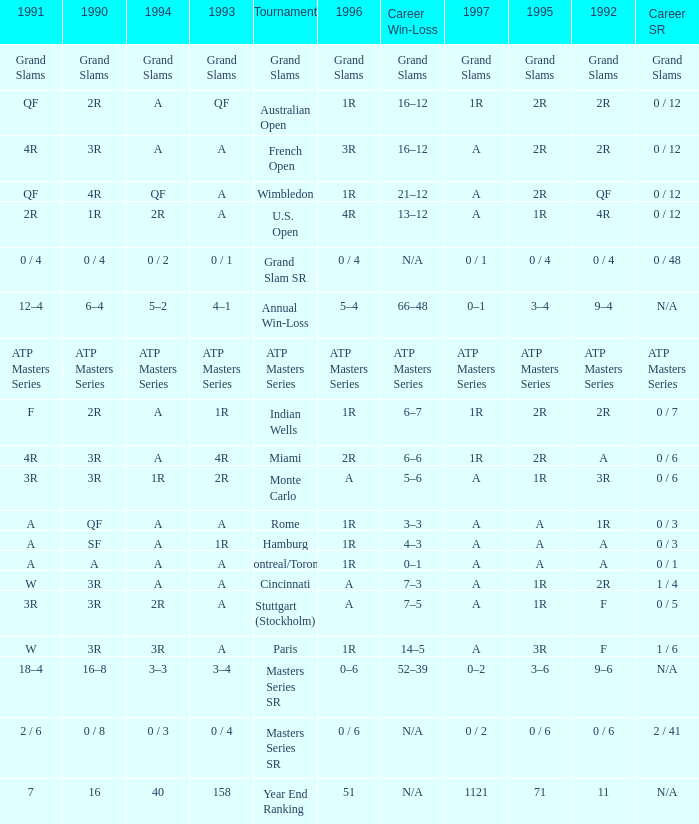What is Tournament, when Career SR is "ATP Masters Series"? ATP Masters Series. Write the full table. {'header': ['1991', '1990', '1994', '1993', 'Tournament', '1996', 'Career Win-Loss', '1997', '1995', '1992', 'Career SR'], 'rows': [['Grand Slams', 'Grand Slams', 'Grand Slams', 'Grand Slams', 'Grand Slams', 'Grand Slams', 'Grand Slams', 'Grand Slams', 'Grand Slams', 'Grand Slams', 'Grand Slams'], ['QF', '2R', 'A', 'QF', 'Australian Open', '1R', '16–12', '1R', '2R', '2R', '0 / 12'], ['4R', '3R', 'A', 'A', 'French Open', '3R', '16–12', 'A', '2R', '2R', '0 / 12'], ['QF', '4R', 'QF', 'A', 'Wimbledon', '1R', '21–12', 'A', '2R', 'QF', '0 / 12'], ['2R', '1R', '2R', 'A', 'U.S. Open', '4R', '13–12', 'A', '1R', '4R', '0 / 12'], ['0 / 4', '0 / 4', '0 / 2', '0 / 1', 'Grand Slam SR', '0 / 4', 'N/A', '0 / 1', '0 / 4', '0 / 4', '0 / 48'], ['12–4', '6–4', '5–2', '4–1', 'Annual Win-Loss', '5–4', '66–48', '0–1', '3–4', '9–4', 'N/A'], ['ATP Masters Series', 'ATP Masters Series', 'ATP Masters Series', 'ATP Masters Series', 'ATP Masters Series', 'ATP Masters Series', 'ATP Masters Series', 'ATP Masters Series', 'ATP Masters Series', 'ATP Masters Series', 'ATP Masters Series'], ['F', '2R', 'A', '1R', 'Indian Wells', '1R', '6–7', '1R', '2R', '2R', '0 / 7'], ['4R', '3R', 'A', '4R', 'Miami', '2R', '6–6', '1R', '2R', 'A', '0 / 6'], ['3R', '3R', '1R', '2R', 'Monte Carlo', 'A', '5–6', 'A', '1R', '3R', '0 / 6'], ['A', 'QF', 'A', 'A', 'Rome', '1R', '3–3', 'A', 'A', '1R', '0 / 3'], ['A', 'SF', 'A', '1R', 'Hamburg', '1R', '4–3', 'A', 'A', 'A', '0 / 3'], ['A', 'A', 'A', 'A', 'Montreal/Toronto', '1R', '0–1', 'A', 'A', 'A', '0 / 1'], ['W', '3R', 'A', 'A', 'Cincinnati', 'A', '7–3', 'A', '1R', '2R', '1 / 4'], ['3R', '3R', '2R', 'A', 'Stuttgart (Stockholm)', 'A', '7–5', 'A', '1R', 'F', '0 / 5'], ['W', '3R', '3R', 'A', 'Paris', '1R', '14–5', 'A', '3R', 'F', '1 / 6'], ['18–4', '16–8', '3–3', '3–4', 'Masters Series SR', '0–6', '52–39', '0–2', '3–6', '9–6', 'N/A'], ['2 / 6', '0 / 8', '0 / 3', '0 / 4', 'Masters Series SR', '0 / 6', 'N/A', '0 / 2', '0 / 6', '0 / 6', '2 / 41'], ['7', '16', '40', '158', 'Year End Ranking', '51', 'N/A', '1121', '71', '11', 'N/A']]} 